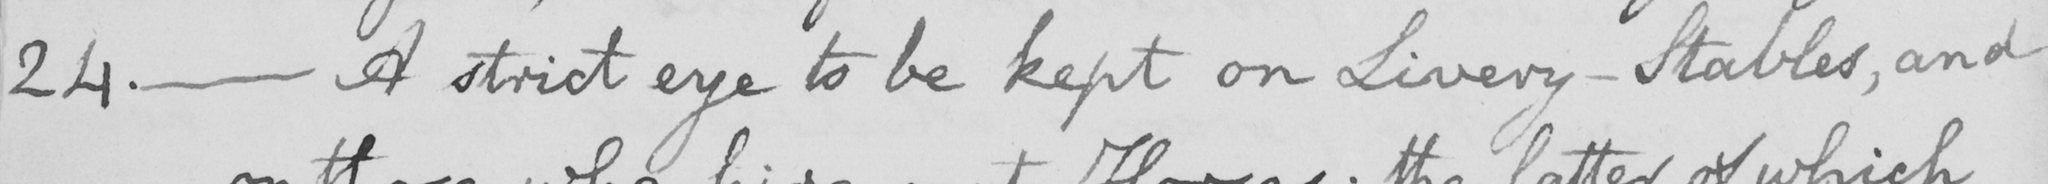Please provide the text content of this handwritten line. 24 .  _  A strict eye to be kept on Livery-Stables , and 